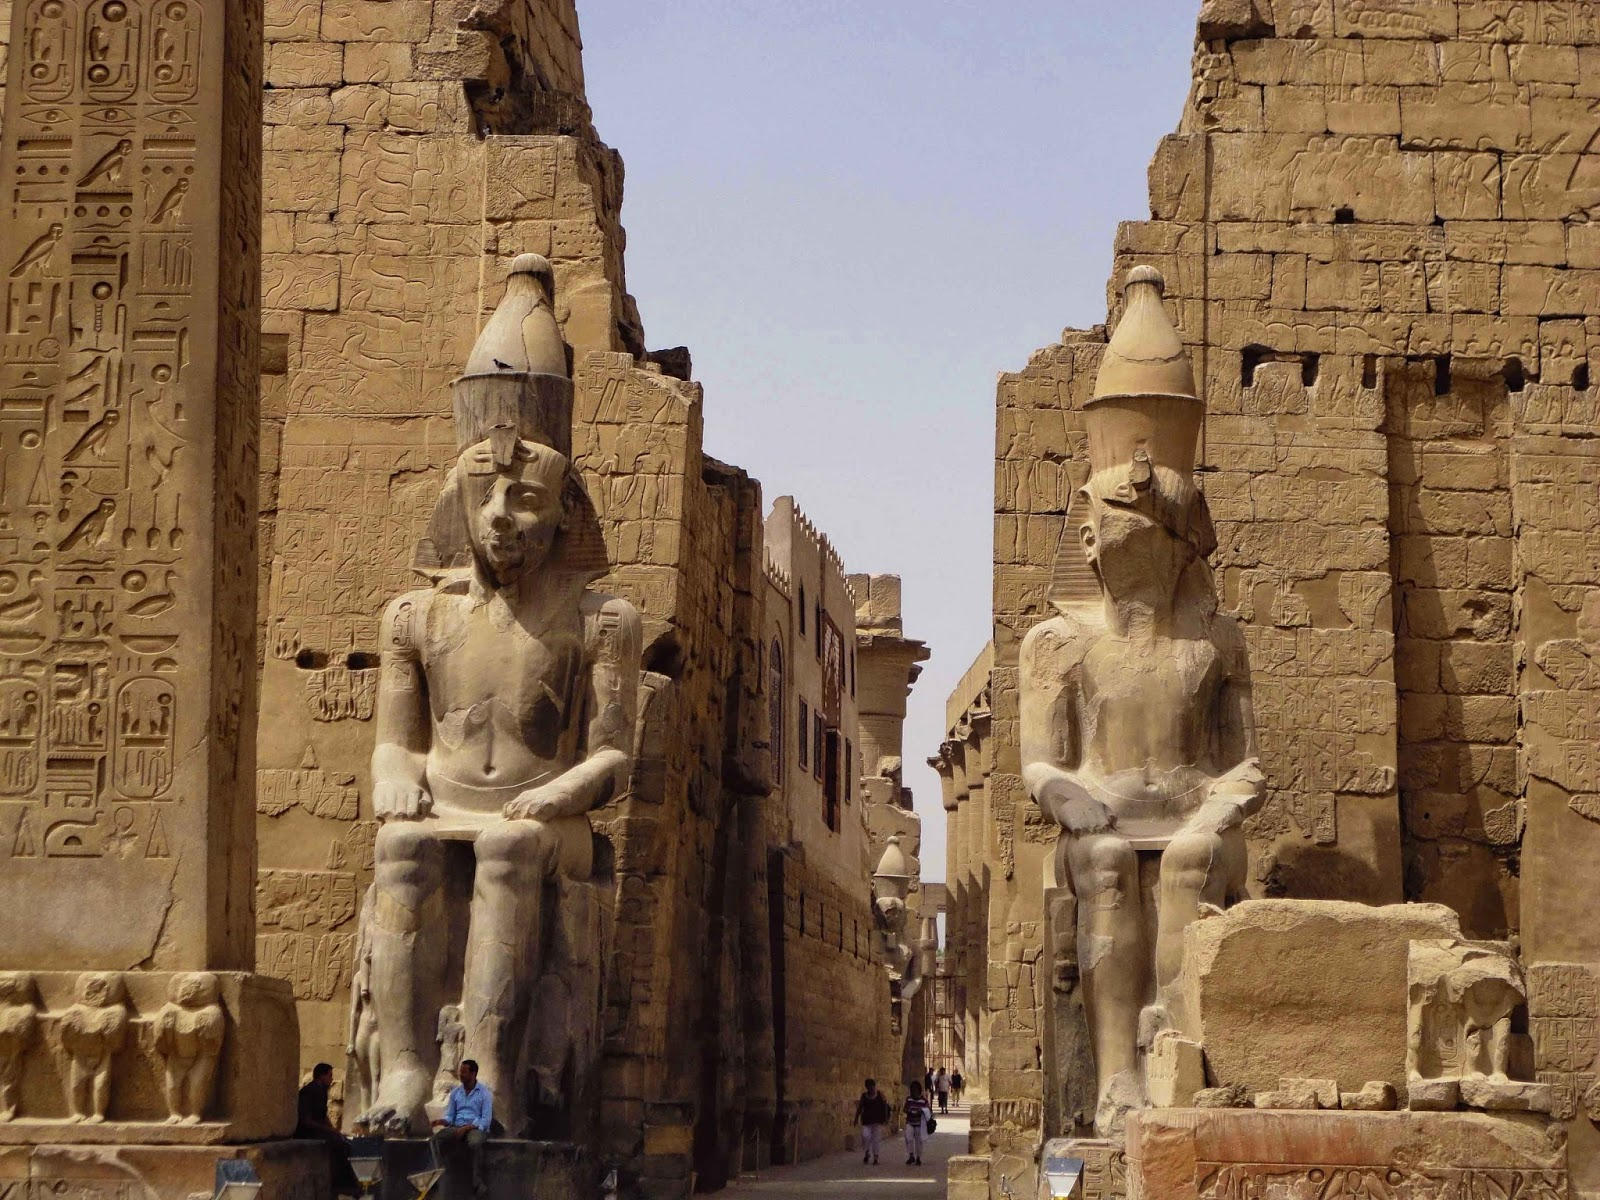What emotions do you think this place evokes? The Luxor Temple evokes a sense of awe and reverence. The massive stone statues and extensive hieroglyphics immerse visitors in the grandeur of ancient Egypt. The weathered statues engender a feeling of timelessness and resilience, while the detailed carvings inspire curiosity and a deep respect for the culture and knowledge of ancient civilizations. It's a place where history feels alive, inviting contemplation and wonder. Can you describe a day in the life of someone who lived here when it was first built? Imagine the bustling atmosphere of Luxor during its prime. As dawn breaks, the temple priests begin their rituals, preparing offerings for the gods. The smell of incense fills the air as chants echo through the halls. Craftsmen and laborers, having completed their work on the statues and walls, discuss the latest progress. Citizens flock to the temple, seeking blessings or delivering tributes. The heat of the midday sun is tempered by the shadows cast by the grand pylons and towering statues.

Visitors, ranging from local farmers to dignitaries from far lands, weave through the columns, admiring the beauty and grandeur of the temple. By evening, as the sky turns golden, the temple grows quieter. The last of the daylight mingles with the flickering light of oil lamps, creating an ethereal atmosphere. The night envelopes the temple, leaving it in serene silence until the cycle begins anew. 